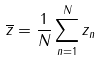<formula> <loc_0><loc_0><loc_500><loc_500>\overline { z } = \frac { 1 } { N } \sum _ { n = 1 } ^ { N } z _ { n }</formula> 